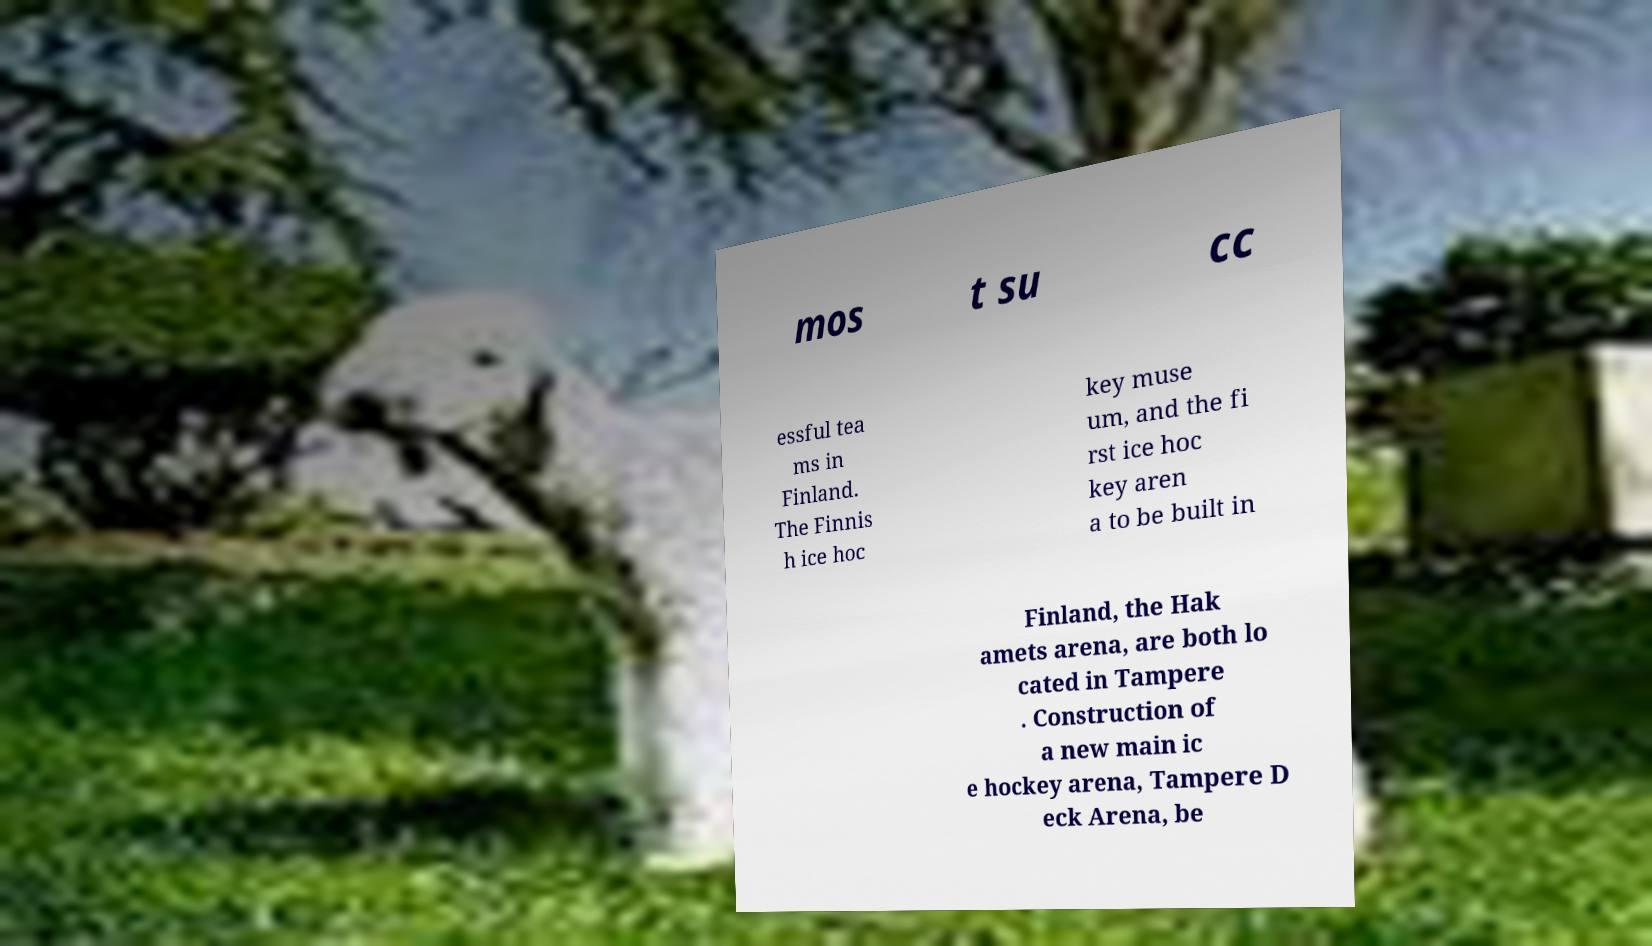Can you accurately transcribe the text from the provided image for me? mos t su cc essful tea ms in Finland. The Finnis h ice hoc key muse um, and the fi rst ice hoc key aren a to be built in Finland, the Hak amets arena, are both lo cated in Tampere . Construction of a new main ic e hockey arena, Tampere D eck Arena, be 